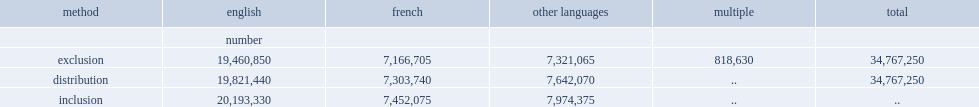What method produces a minimum estimate of the population whose mother tongue is english, french or a language other than english or french. Exclusion. How many respondents who reported more than one mother tongue in 2016 are not included in any of the three main groups? 818630.0. 